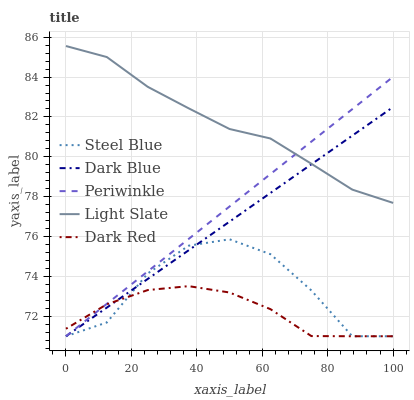Does Dark Blue have the minimum area under the curve?
Answer yes or no. No. Does Dark Blue have the maximum area under the curve?
Answer yes or no. No. Is Dark Blue the smoothest?
Answer yes or no. No. Is Dark Blue the roughest?
Answer yes or no. No. Does Dark Blue have the highest value?
Answer yes or no. No. Is Dark Red less than Light Slate?
Answer yes or no. Yes. Is Light Slate greater than Dark Red?
Answer yes or no. Yes. Does Dark Red intersect Light Slate?
Answer yes or no. No. 